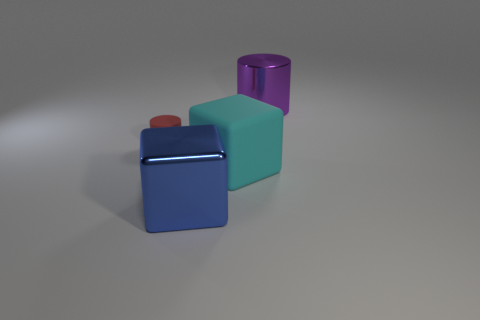What size is the thing that is in front of the red cylinder and behind the large metallic cube?
Make the answer very short. Large. What number of other things are there of the same size as the cyan rubber block?
Your response must be concise. 2. What is the color of the shiny thing that is in front of the tiny matte thing in front of the large object behind the big rubber thing?
Make the answer very short. Blue. There is a big object that is on the left side of the big purple metal thing and behind the blue object; what shape is it?
Provide a short and direct response. Cube. How many other objects are the same shape as the purple metal thing?
Ensure brevity in your answer.  1. There is a rubber object right of the cylinder in front of the purple shiny cylinder behind the red thing; what shape is it?
Ensure brevity in your answer.  Cube. How many things are cyan matte cubes or rubber things to the right of the small red thing?
Provide a succinct answer. 1. There is a shiny object in front of the tiny red rubber object; does it have the same shape as the matte object that is in front of the red rubber thing?
Make the answer very short. Yes. What number of things are blue matte cylinders or small rubber objects?
Offer a very short reply. 1. Is there a large green cylinder?
Make the answer very short. No. 